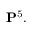<formula> <loc_0><loc_0><loc_500><loc_500>P ^ { 5 } .</formula> 